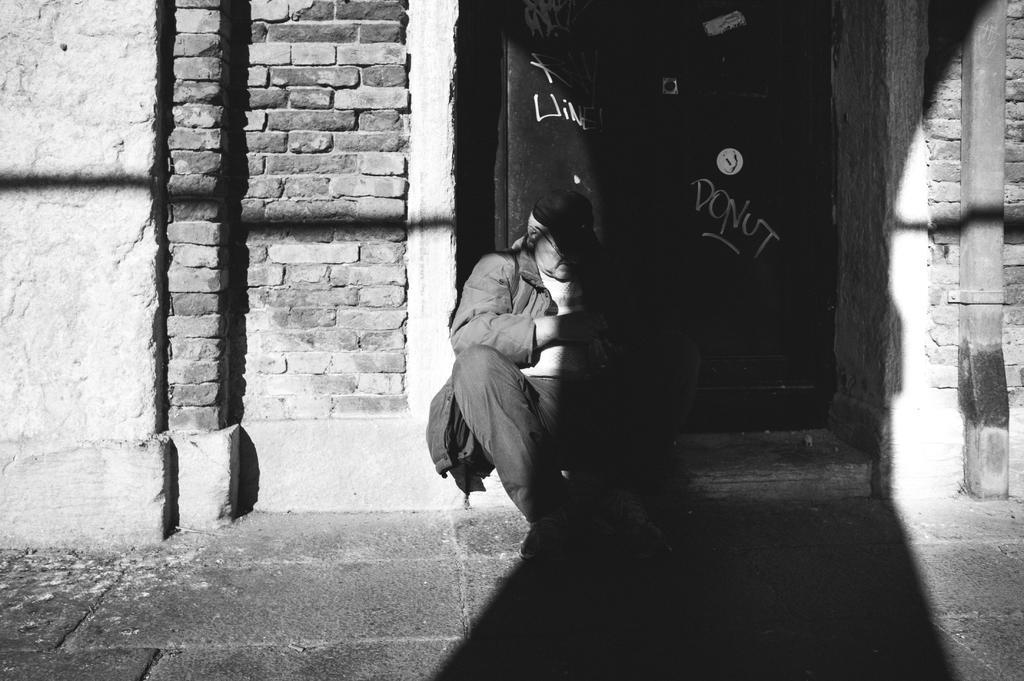In one or two sentences, can you explain what this image depicts? In this picture we can see a person is seated in front of the door, and we can find brick wall. 